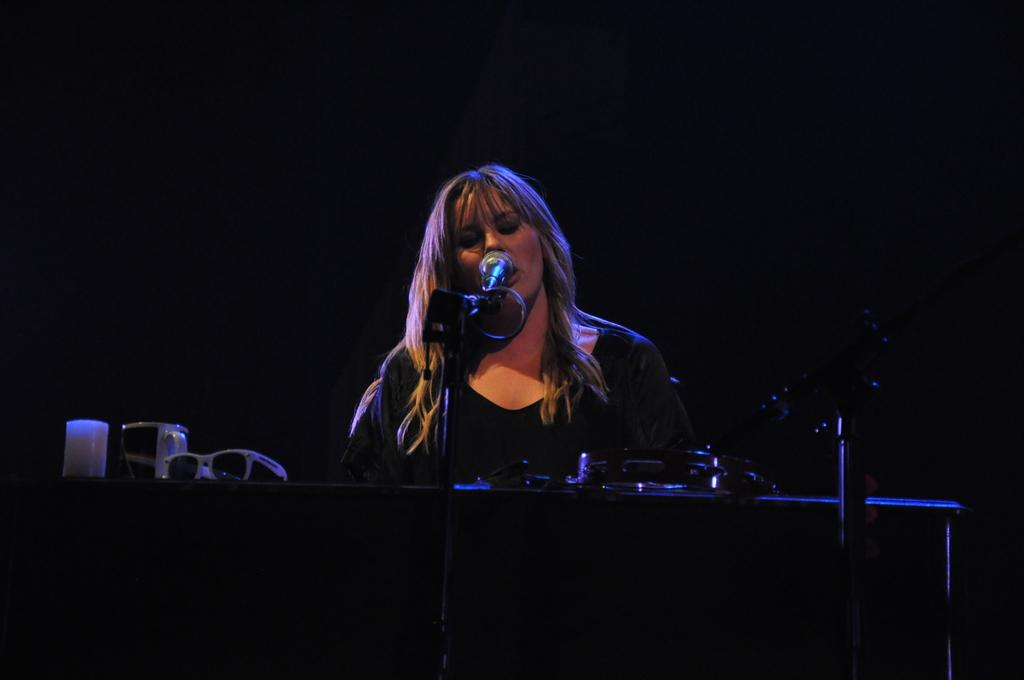What is located at the bottom of the image? There is a table at the bottom of the image. What objects are on the table? There are glasses, shades, and a microphone on the table. Who is present in the image? A woman is sitting behind the table. What is the weight of the carriage in the image? There is no carriage present in the image, so it is not possible to determine its weight. 